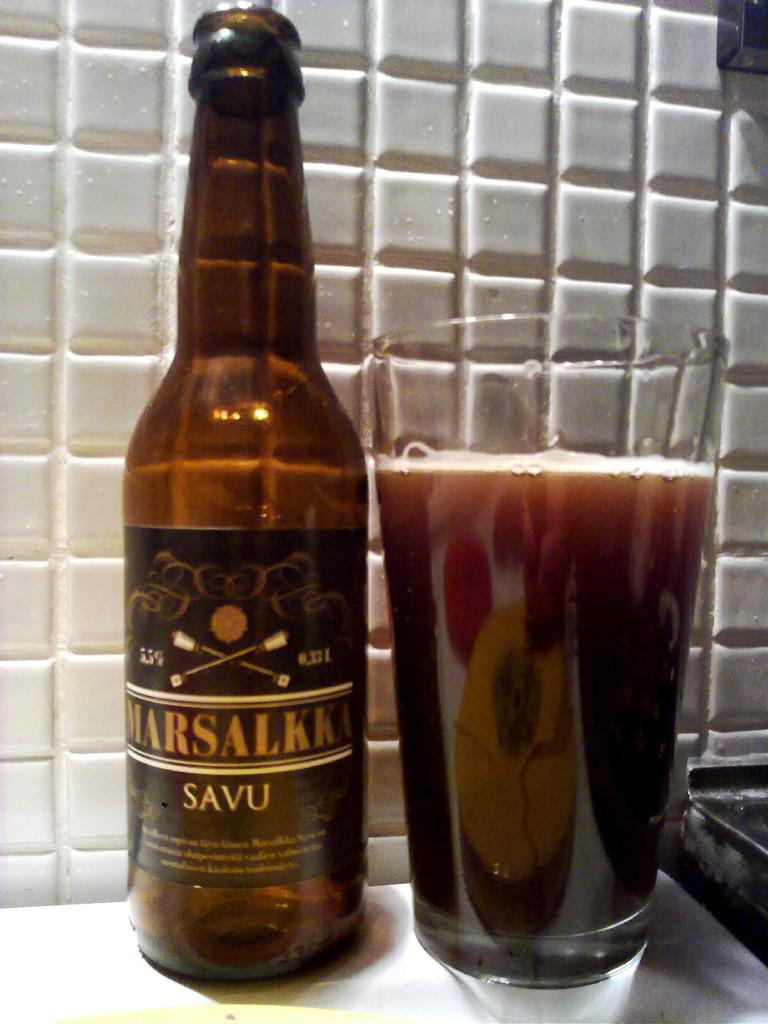What brand is the beer?
Make the answer very short. Marsalkka. 